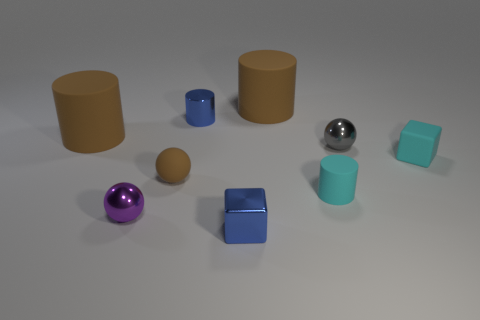Is the color of the tiny cylinder that is on the right side of the small blue block the same as the block that is behind the small shiny block?
Keep it short and to the point. Yes. How big is the sphere on the right side of the tiny blue metal thing that is in front of the tiny cyan cylinder?
Give a very brief answer. Small. What is the shape of the shiny thing that is the same color as the shiny cylinder?
Ensure brevity in your answer.  Cube. How many blocks are either tiny green matte things or purple things?
Ensure brevity in your answer.  0. Does the purple thing have the same size as the blue object behind the rubber ball?
Your answer should be compact. Yes. Are there more blue metal objects in front of the small cyan block than green blocks?
Offer a very short reply. Yes. There is a cyan thing that is made of the same material as the cyan cylinder; what is its size?
Give a very brief answer. Small. Are there any shiny things that have the same color as the metal cylinder?
Give a very brief answer. Yes. How many objects are brown rubber things or cylinders that are in front of the tiny gray thing?
Ensure brevity in your answer.  4. Are there more big purple blocks than tiny purple metal balls?
Offer a terse response. No. 